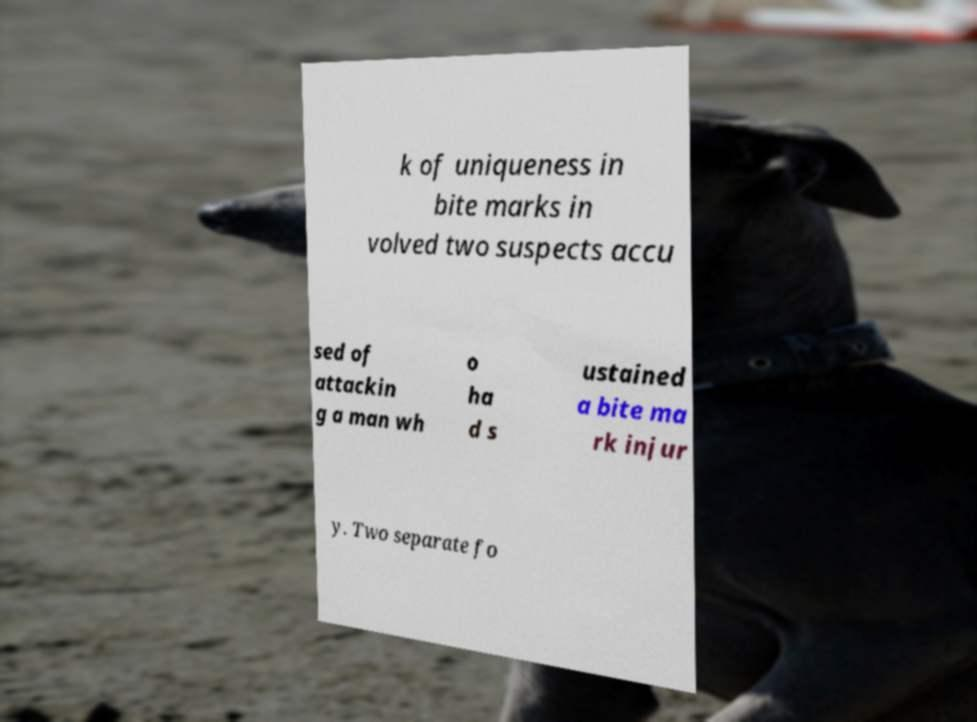Can you accurately transcribe the text from the provided image for me? k of uniqueness in bite marks in volved two suspects accu sed of attackin g a man wh o ha d s ustained a bite ma rk injur y. Two separate fo 